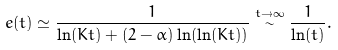Convert formula to latex. <formula><loc_0><loc_0><loc_500><loc_500>\ e ( t ) \simeq \frac { 1 } { \ln ( K t ) + ( 2 - \alpha ) \ln ( \ln ( K t ) ) } \stackrel { t \rightarrow \infty } { \sim } \frac { 1 } { \ln ( t ) } .</formula> 